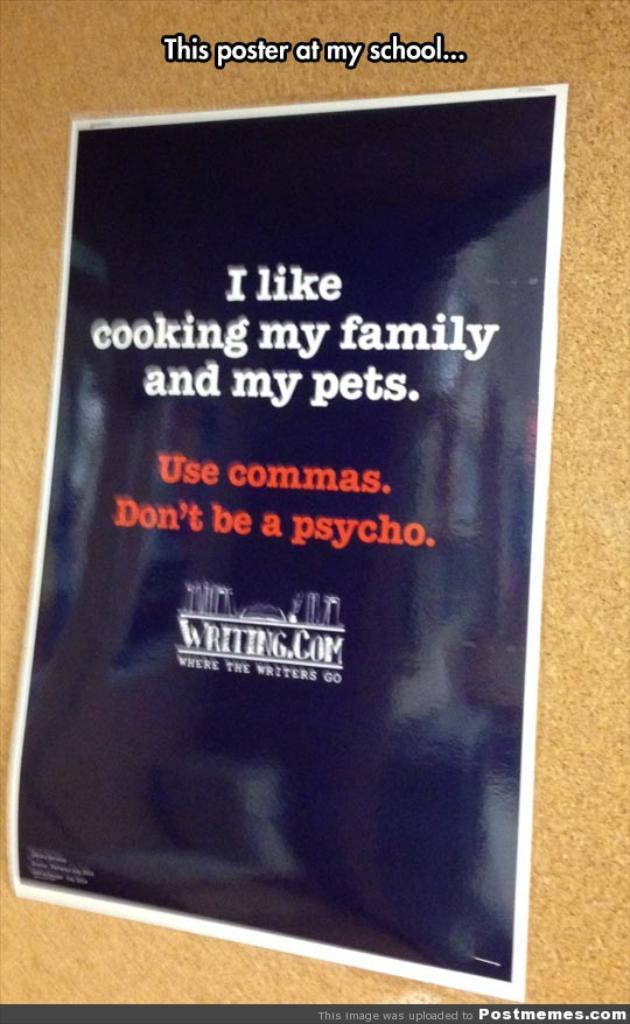<image>
Describe the image concisely. a poster that tells students to use commas and dont be psycho 